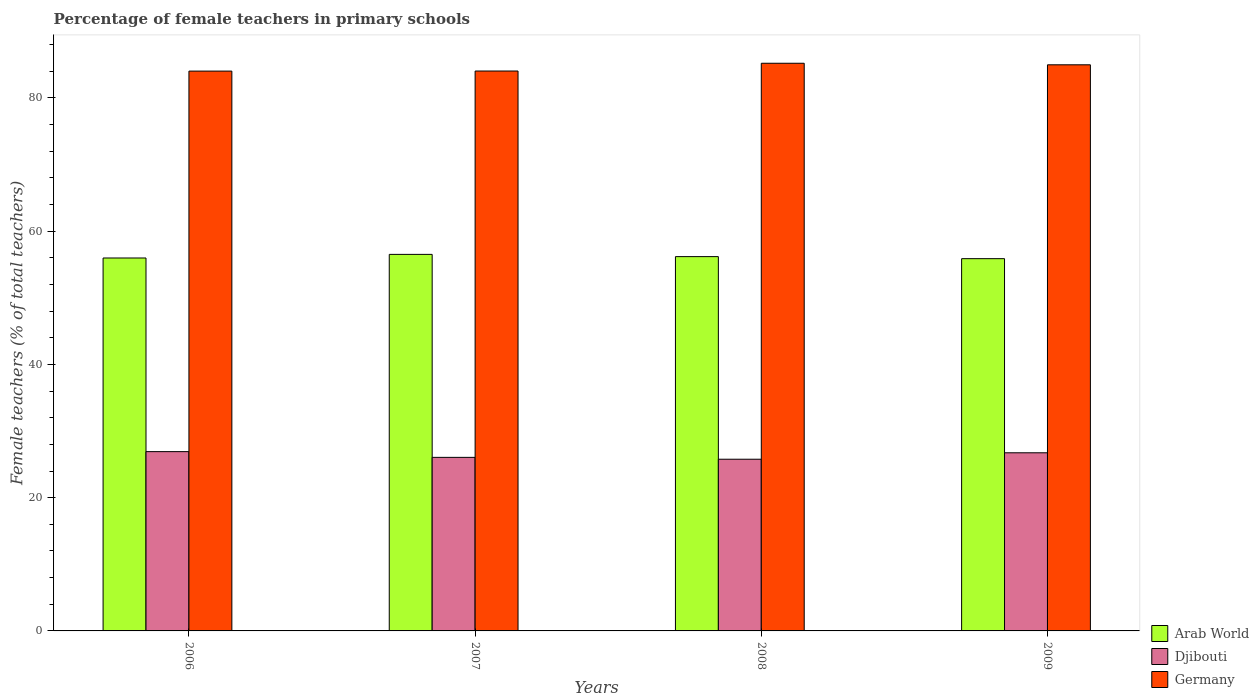How many bars are there on the 2nd tick from the left?
Provide a succinct answer. 3. What is the percentage of female teachers in Arab World in 2006?
Give a very brief answer. 55.97. Across all years, what is the maximum percentage of female teachers in Germany?
Give a very brief answer. 85.2. Across all years, what is the minimum percentage of female teachers in Germany?
Make the answer very short. 84.02. In which year was the percentage of female teachers in Germany minimum?
Provide a succinct answer. 2006. What is the total percentage of female teachers in Arab World in the graph?
Your answer should be compact. 224.54. What is the difference between the percentage of female teachers in Djibouti in 2008 and that in 2009?
Offer a terse response. -0.97. What is the difference between the percentage of female teachers in Germany in 2007 and the percentage of female teachers in Djibouti in 2009?
Your response must be concise. 57.3. What is the average percentage of female teachers in Germany per year?
Provide a succinct answer. 84.56. In the year 2008, what is the difference between the percentage of female teachers in Germany and percentage of female teachers in Arab World?
Make the answer very short. 29.02. In how many years, is the percentage of female teachers in Germany greater than 52 %?
Offer a terse response. 4. What is the ratio of the percentage of female teachers in Djibouti in 2006 to that in 2007?
Keep it short and to the point. 1.03. What is the difference between the highest and the second highest percentage of female teachers in Djibouti?
Your answer should be very brief. 0.17. What is the difference between the highest and the lowest percentage of female teachers in Djibouti?
Offer a very short reply. 1.14. In how many years, is the percentage of female teachers in Arab World greater than the average percentage of female teachers in Arab World taken over all years?
Give a very brief answer. 2. Is the sum of the percentage of female teachers in Germany in 2006 and 2009 greater than the maximum percentage of female teachers in Djibouti across all years?
Your answer should be compact. Yes. What does the 2nd bar from the left in 2007 represents?
Give a very brief answer. Djibouti. What does the 1st bar from the right in 2009 represents?
Offer a terse response. Germany. Is it the case that in every year, the sum of the percentage of female teachers in Djibouti and percentage of female teachers in Arab World is greater than the percentage of female teachers in Germany?
Make the answer very short. No. Are all the bars in the graph horizontal?
Ensure brevity in your answer.  No. How many years are there in the graph?
Your answer should be compact. 4. What is the difference between two consecutive major ticks on the Y-axis?
Provide a succinct answer. 20. How are the legend labels stacked?
Your answer should be compact. Vertical. What is the title of the graph?
Your answer should be compact. Percentage of female teachers in primary schools. Does "European Union" appear as one of the legend labels in the graph?
Offer a terse response. No. What is the label or title of the Y-axis?
Your answer should be compact. Female teachers (% of total teachers). What is the Female teachers (% of total teachers) in Arab World in 2006?
Provide a short and direct response. 55.97. What is the Female teachers (% of total teachers) in Djibouti in 2006?
Provide a succinct answer. 26.91. What is the Female teachers (% of total teachers) in Germany in 2006?
Offer a terse response. 84.02. What is the Female teachers (% of total teachers) of Arab World in 2007?
Your answer should be very brief. 56.51. What is the Female teachers (% of total teachers) of Djibouti in 2007?
Your response must be concise. 26.05. What is the Female teachers (% of total teachers) of Germany in 2007?
Your response must be concise. 84.03. What is the Female teachers (% of total teachers) in Arab World in 2008?
Your response must be concise. 56.18. What is the Female teachers (% of total teachers) of Djibouti in 2008?
Your answer should be compact. 25.77. What is the Female teachers (% of total teachers) in Germany in 2008?
Your answer should be compact. 85.2. What is the Female teachers (% of total teachers) of Arab World in 2009?
Offer a terse response. 55.87. What is the Female teachers (% of total teachers) of Djibouti in 2009?
Your response must be concise. 26.74. What is the Female teachers (% of total teachers) in Germany in 2009?
Make the answer very short. 84.97. Across all years, what is the maximum Female teachers (% of total teachers) of Arab World?
Offer a very short reply. 56.51. Across all years, what is the maximum Female teachers (% of total teachers) of Djibouti?
Your answer should be very brief. 26.91. Across all years, what is the maximum Female teachers (% of total teachers) of Germany?
Provide a short and direct response. 85.2. Across all years, what is the minimum Female teachers (% of total teachers) in Arab World?
Give a very brief answer. 55.87. Across all years, what is the minimum Female teachers (% of total teachers) in Djibouti?
Keep it short and to the point. 25.77. Across all years, what is the minimum Female teachers (% of total teachers) in Germany?
Give a very brief answer. 84.02. What is the total Female teachers (% of total teachers) in Arab World in the graph?
Your response must be concise. 224.54. What is the total Female teachers (% of total teachers) of Djibouti in the graph?
Provide a short and direct response. 105.46. What is the total Female teachers (% of total teachers) of Germany in the graph?
Your answer should be very brief. 338.22. What is the difference between the Female teachers (% of total teachers) in Arab World in 2006 and that in 2007?
Make the answer very short. -0.54. What is the difference between the Female teachers (% of total teachers) in Djibouti in 2006 and that in 2007?
Offer a very short reply. 0.86. What is the difference between the Female teachers (% of total teachers) of Germany in 2006 and that in 2007?
Ensure brevity in your answer.  -0.01. What is the difference between the Female teachers (% of total teachers) in Arab World in 2006 and that in 2008?
Provide a short and direct response. -0.21. What is the difference between the Female teachers (% of total teachers) in Djibouti in 2006 and that in 2008?
Provide a succinct answer. 1.14. What is the difference between the Female teachers (% of total teachers) of Germany in 2006 and that in 2008?
Give a very brief answer. -1.18. What is the difference between the Female teachers (% of total teachers) of Arab World in 2006 and that in 2009?
Provide a succinct answer. 0.1. What is the difference between the Female teachers (% of total teachers) in Djibouti in 2006 and that in 2009?
Provide a succinct answer. 0.17. What is the difference between the Female teachers (% of total teachers) of Germany in 2006 and that in 2009?
Keep it short and to the point. -0.95. What is the difference between the Female teachers (% of total teachers) of Arab World in 2007 and that in 2008?
Give a very brief answer. 0.34. What is the difference between the Female teachers (% of total teachers) in Djibouti in 2007 and that in 2008?
Your answer should be compact. 0.28. What is the difference between the Female teachers (% of total teachers) of Germany in 2007 and that in 2008?
Give a very brief answer. -1.17. What is the difference between the Female teachers (% of total teachers) of Arab World in 2007 and that in 2009?
Provide a short and direct response. 0.64. What is the difference between the Female teachers (% of total teachers) of Djibouti in 2007 and that in 2009?
Your answer should be compact. -0.69. What is the difference between the Female teachers (% of total teachers) in Germany in 2007 and that in 2009?
Offer a terse response. -0.94. What is the difference between the Female teachers (% of total teachers) of Arab World in 2008 and that in 2009?
Keep it short and to the point. 0.31. What is the difference between the Female teachers (% of total teachers) in Djibouti in 2008 and that in 2009?
Your answer should be very brief. -0.97. What is the difference between the Female teachers (% of total teachers) in Germany in 2008 and that in 2009?
Provide a short and direct response. 0.23. What is the difference between the Female teachers (% of total teachers) in Arab World in 2006 and the Female teachers (% of total teachers) in Djibouti in 2007?
Give a very brief answer. 29.92. What is the difference between the Female teachers (% of total teachers) of Arab World in 2006 and the Female teachers (% of total teachers) of Germany in 2007?
Your response must be concise. -28.06. What is the difference between the Female teachers (% of total teachers) in Djibouti in 2006 and the Female teachers (% of total teachers) in Germany in 2007?
Ensure brevity in your answer.  -57.12. What is the difference between the Female teachers (% of total teachers) of Arab World in 2006 and the Female teachers (% of total teachers) of Djibouti in 2008?
Ensure brevity in your answer.  30.2. What is the difference between the Female teachers (% of total teachers) in Arab World in 2006 and the Female teachers (% of total teachers) in Germany in 2008?
Ensure brevity in your answer.  -29.23. What is the difference between the Female teachers (% of total teachers) of Djibouti in 2006 and the Female teachers (% of total teachers) of Germany in 2008?
Keep it short and to the point. -58.29. What is the difference between the Female teachers (% of total teachers) in Arab World in 2006 and the Female teachers (% of total teachers) in Djibouti in 2009?
Make the answer very short. 29.24. What is the difference between the Female teachers (% of total teachers) in Arab World in 2006 and the Female teachers (% of total teachers) in Germany in 2009?
Provide a succinct answer. -29. What is the difference between the Female teachers (% of total teachers) in Djibouti in 2006 and the Female teachers (% of total teachers) in Germany in 2009?
Your answer should be very brief. -58.06. What is the difference between the Female teachers (% of total teachers) in Arab World in 2007 and the Female teachers (% of total teachers) in Djibouti in 2008?
Provide a short and direct response. 30.74. What is the difference between the Female teachers (% of total teachers) in Arab World in 2007 and the Female teachers (% of total teachers) in Germany in 2008?
Offer a very short reply. -28.69. What is the difference between the Female teachers (% of total teachers) in Djibouti in 2007 and the Female teachers (% of total teachers) in Germany in 2008?
Your response must be concise. -59.15. What is the difference between the Female teachers (% of total teachers) in Arab World in 2007 and the Female teachers (% of total teachers) in Djibouti in 2009?
Provide a succinct answer. 29.78. What is the difference between the Female teachers (% of total teachers) in Arab World in 2007 and the Female teachers (% of total teachers) in Germany in 2009?
Provide a succinct answer. -28.45. What is the difference between the Female teachers (% of total teachers) of Djibouti in 2007 and the Female teachers (% of total teachers) of Germany in 2009?
Ensure brevity in your answer.  -58.92. What is the difference between the Female teachers (% of total teachers) in Arab World in 2008 and the Female teachers (% of total teachers) in Djibouti in 2009?
Ensure brevity in your answer.  29.44. What is the difference between the Female teachers (% of total teachers) in Arab World in 2008 and the Female teachers (% of total teachers) in Germany in 2009?
Offer a terse response. -28.79. What is the difference between the Female teachers (% of total teachers) in Djibouti in 2008 and the Female teachers (% of total teachers) in Germany in 2009?
Make the answer very short. -59.2. What is the average Female teachers (% of total teachers) of Arab World per year?
Your response must be concise. 56.13. What is the average Female teachers (% of total teachers) in Djibouti per year?
Make the answer very short. 26.37. What is the average Female teachers (% of total teachers) of Germany per year?
Offer a very short reply. 84.56. In the year 2006, what is the difference between the Female teachers (% of total teachers) in Arab World and Female teachers (% of total teachers) in Djibouti?
Ensure brevity in your answer.  29.06. In the year 2006, what is the difference between the Female teachers (% of total teachers) in Arab World and Female teachers (% of total teachers) in Germany?
Your answer should be compact. -28.05. In the year 2006, what is the difference between the Female teachers (% of total teachers) in Djibouti and Female teachers (% of total teachers) in Germany?
Provide a short and direct response. -57.11. In the year 2007, what is the difference between the Female teachers (% of total teachers) in Arab World and Female teachers (% of total teachers) in Djibouti?
Make the answer very short. 30.47. In the year 2007, what is the difference between the Female teachers (% of total teachers) in Arab World and Female teachers (% of total teachers) in Germany?
Keep it short and to the point. -27.52. In the year 2007, what is the difference between the Female teachers (% of total teachers) of Djibouti and Female teachers (% of total teachers) of Germany?
Offer a very short reply. -57.98. In the year 2008, what is the difference between the Female teachers (% of total teachers) in Arab World and Female teachers (% of total teachers) in Djibouti?
Provide a succinct answer. 30.41. In the year 2008, what is the difference between the Female teachers (% of total teachers) in Arab World and Female teachers (% of total teachers) in Germany?
Give a very brief answer. -29.02. In the year 2008, what is the difference between the Female teachers (% of total teachers) in Djibouti and Female teachers (% of total teachers) in Germany?
Keep it short and to the point. -59.43. In the year 2009, what is the difference between the Female teachers (% of total teachers) in Arab World and Female teachers (% of total teachers) in Djibouti?
Give a very brief answer. 29.14. In the year 2009, what is the difference between the Female teachers (% of total teachers) in Arab World and Female teachers (% of total teachers) in Germany?
Make the answer very short. -29.1. In the year 2009, what is the difference between the Female teachers (% of total teachers) of Djibouti and Female teachers (% of total teachers) of Germany?
Your response must be concise. -58.23. What is the ratio of the Female teachers (% of total teachers) of Djibouti in 2006 to that in 2007?
Your answer should be very brief. 1.03. What is the ratio of the Female teachers (% of total teachers) in Germany in 2006 to that in 2007?
Your response must be concise. 1. What is the ratio of the Female teachers (% of total teachers) of Djibouti in 2006 to that in 2008?
Offer a very short reply. 1.04. What is the ratio of the Female teachers (% of total teachers) in Germany in 2006 to that in 2008?
Offer a terse response. 0.99. What is the ratio of the Female teachers (% of total teachers) in Arab World in 2006 to that in 2009?
Ensure brevity in your answer.  1. What is the ratio of the Female teachers (% of total teachers) of Djibouti in 2006 to that in 2009?
Make the answer very short. 1.01. What is the ratio of the Female teachers (% of total teachers) in Germany in 2006 to that in 2009?
Your answer should be very brief. 0.99. What is the ratio of the Female teachers (% of total teachers) in Arab World in 2007 to that in 2008?
Give a very brief answer. 1.01. What is the ratio of the Female teachers (% of total teachers) of Djibouti in 2007 to that in 2008?
Your answer should be compact. 1.01. What is the ratio of the Female teachers (% of total teachers) of Germany in 2007 to that in 2008?
Make the answer very short. 0.99. What is the ratio of the Female teachers (% of total teachers) of Arab World in 2007 to that in 2009?
Ensure brevity in your answer.  1.01. What is the ratio of the Female teachers (% of total teachers) of Djibouti in 2007 to that in 2009?
Your answer should be compact. 0.97. What is the ratio of the Female teachers (% of total teachers) of Germany in 2007 to that in 2009?
Keep it short and to the point. 0.99. What is the ratio of the Female teachers (% of total teachers) in Arab World in 2008 to that in 2009?
Your response must be concise. 1.01. What is the ratio of the Female teachers (% of total teachers) in Djibouti in 2008 to that in 2009?
Your response must be concise. 0.96. What is the ratio of the Female teachers (% of total teachers) in Germany in 2008 to that in 2009?
Your answer should be very brief. 1. What is the difference between the highest and the second highest Female teachers (% of total teachers) in Arab World?
Your response must be concise. 0.34. What is the difference between the highest and the second highest Female teachers (% of total teachers) in Djibouti?
Keep it short and to the point. 0.17. What is the difference between the highest and the second highest Female teachers (% of total teachers) in Germany?
Your answer should be very brief. 0.23. What is the difference between the highest and the lowest Female teachers (% of total teachers) of Arab World?
Offer a terse response. 0.64. What is the difference between the highest and the lowest Female teachers (% of total teachers) in Djibouti?
Keep it short and to the point. 1.14. What is the difference between the highest and the lowest Female teachers (% of total teachers) in Germany?
Offer a very short reply. 1.18. 